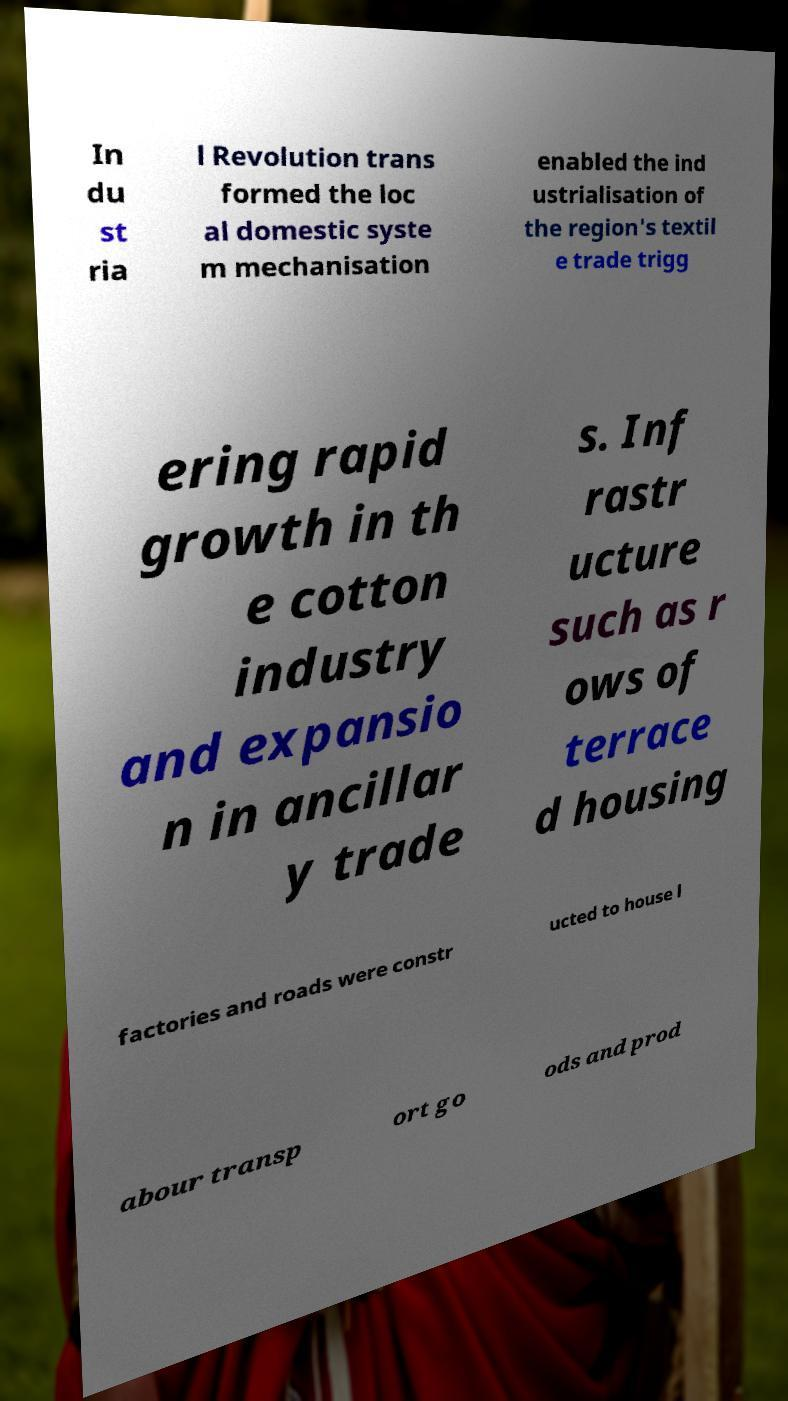Can you read and provide the text displayed in the image?This photo seems to have some interesting text. Can you extract and type it out for me? In du st ria l Revolution trans formed the loc al domestic syste m mechanisation enabled the ind ustrialisation of the region's textil e trade trigg ering rapid growth in th e cotton industry and expansio n in ancillar y trade s. Inf rastr ucture such as r ows of terrace d housing factories and roads were constr ucted to house l abour transp ort go ods and prod 